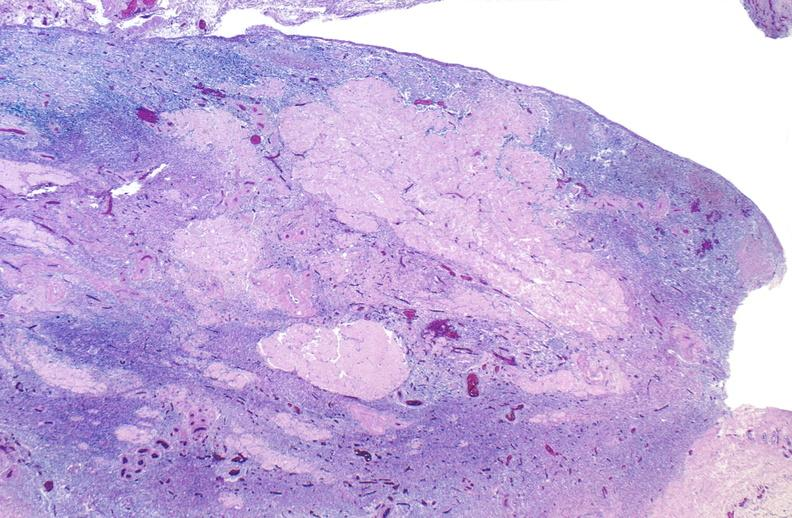s amyloidosis present?
Answer the question using a single word or phrase. No 